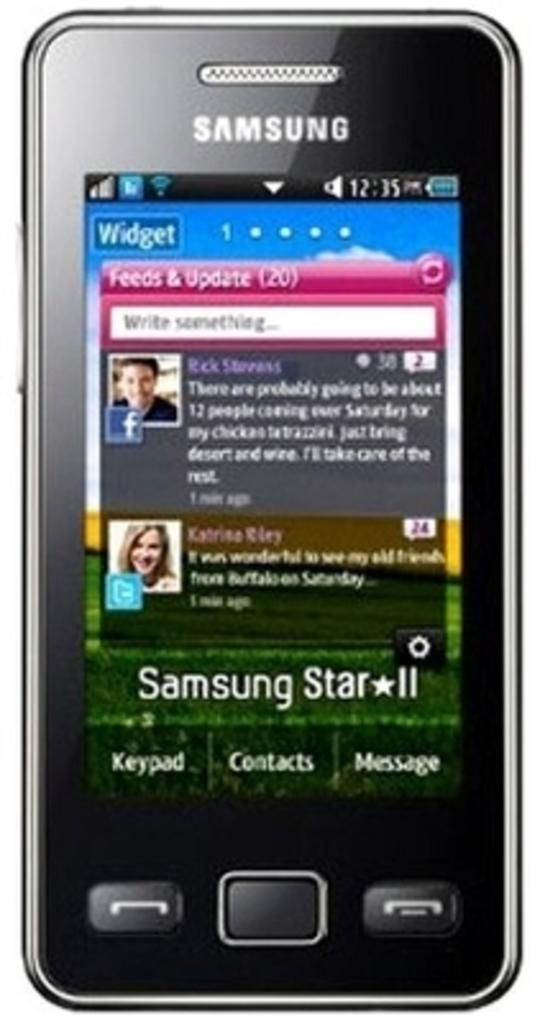<image>
Write a terse but informative summary of the picture. A phone which has the words Samsung Star II at the bottom. 